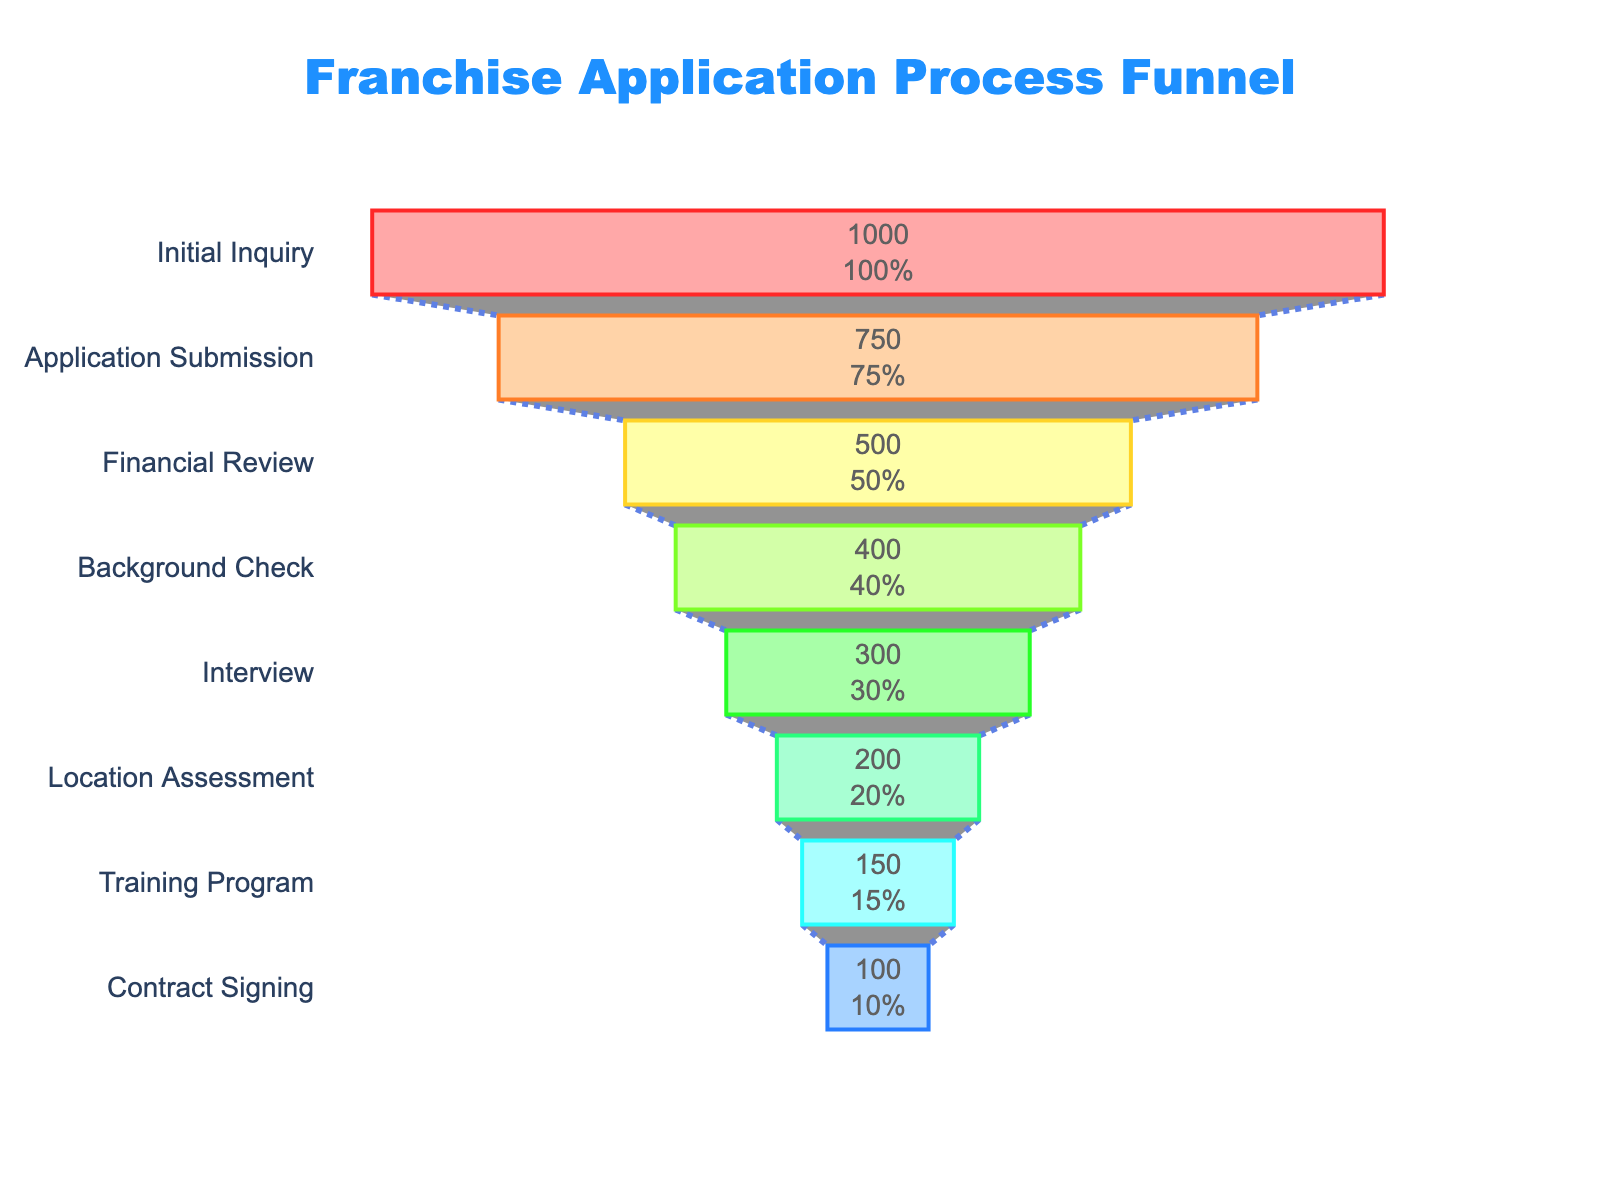What is the title of the funnel chart? The title of the funnel chart is located at the top and provides an overview of what the chart represents. Just by reading it, you can understand the main topic the chart covers.
Answer: Franchise Application Process Funnel How many applicants reached the Interview stage? The funnel chart displays the number of applicants for each stage visually and with labels inside each section. Find the section labeled "Interview" and read the number of applicants.
Answer: 300 How many stages are there in the franchise application process? The funnel chart shows different stages of the application process. By counting each labeled stage from top to bottom, you can determine the total number of stages presented.
Answer: 8 What percentage of applicants reached the Training Program stage? The funnel chart also provides percentage information for each stage relative to the initial number of applicants. Look for the percentage label inside the "Training Program" stage.
Answer: 15% What is the most significant drop in the number of applicants between two consecutive stages? To determine the most significant drop, compare the number of applicants between each consecutive stage and find the largest difference. Calculate the decrease between each pair of stages and identify the largest value.
Answer: From Application Submission (750) to Financial Review (500) How many applicants did not make it past the Financial Review stage? First, find the number of applicants that reached the Financial Review stage. Then, subtract the number of applicants that made it to the next stage (Background Check).
Answer: 500 - 400 = 100 What is the success rate from Initial Inquiry to Contract Signing? To calculate the success rate, divide the number of applicants at the final stage (Contract Signing) by the number of applicants at the initial stage (Initial Inquiry) and multiply by 100 to get the percentage.
Answer: (100 / 1000) * 100 = 10% Which stage has the second-lowest number of applicants? List the number of applicants for each stage and identify the three lowest values. The stage with the second-lowest value will be the answer.
Answer: Training Program (150) How many applicants passed the Background Check stage? The funnel chart provides the number of applicants for each stage. Find the section labeled "Background Check" and read the number of applicants to determine how many passed this stage.
Answer: 400 Which stage witnessed a 50% reduction in applicants? Look for a stage where the number of applicants is half of the number of applicants at the previous stage. Calculate the percentage reduction between consecutive stages and find the one with a 50% reduction.
Answer: Location Assessment from Interview (300) to Location Assessment (200) 